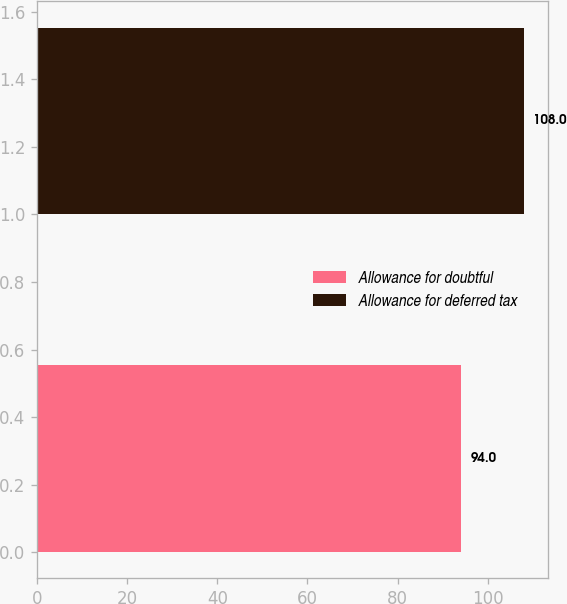Convert chart. <chart><loc_0><loc_0><loc_500><loc_500><bar_chart><fcel>Allowance for doubtful<fcel>Allowance for deferred tax<nl><fcel>94<fcel>108<nl></chart> 